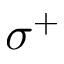<formula> <loc_0><loc_0><loc_500><loc_500>\sigma ^ { + }</formula> 